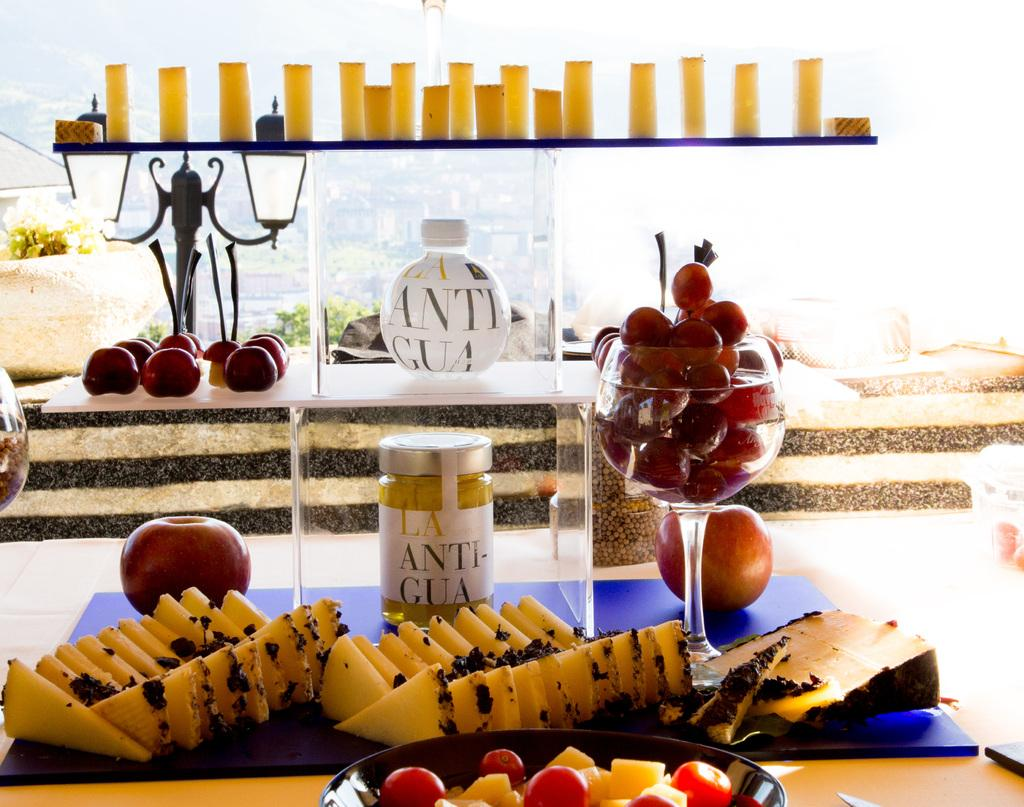What type of container is visible in the image? There is a bowl in the image. What type of fruit can be seen in the image? There are grapes and apples in the image. What other food items are present in the image? There is bread and cake, as well as other food items. What can be seen in the background of the image? There are trees and buildings in the background of the image. What is located on the left side of the image? There is a plant on the left side of the image. What type of flesh can be seen on the trees in the image? There is no flesh visible on the trees in the image; they are not alive. What is the title of the image? The image does not have a title, as it is a photograph or illustration and not a piece of literature or art with a specific title. 